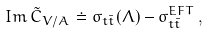Convert formula to latex. <formula><loc_0><loc_0><loc_500><loc_500>I m \, \tilde { C } _ { V / A } \doteq \sigma _ { t \bar { t } } ( \Lambda ) - \sigma _ { t \bar { t } } ^ { E F T } \, ,</formula> 